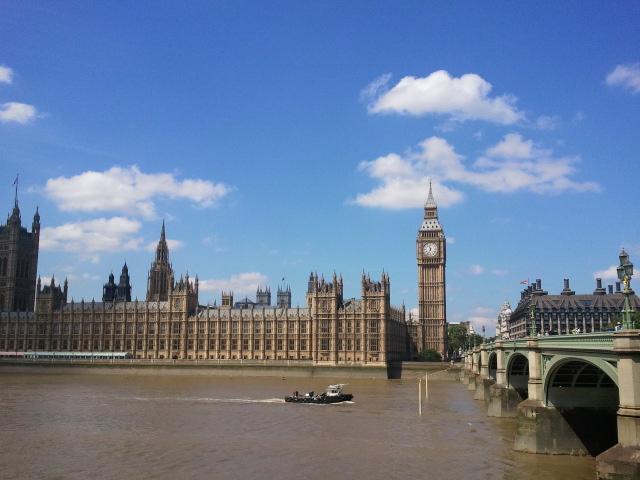How many clocks are there?
Give a very brief answer. 1. How many clocks are pictured?
Give a very brief answer. 1. 